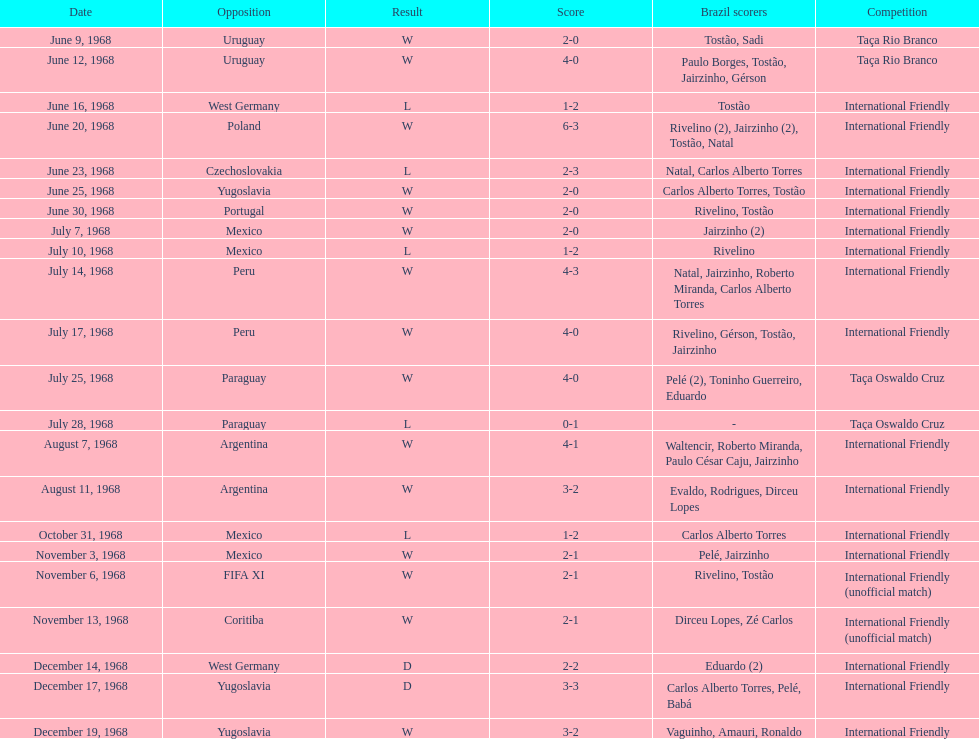How many matches are wins? 15. 